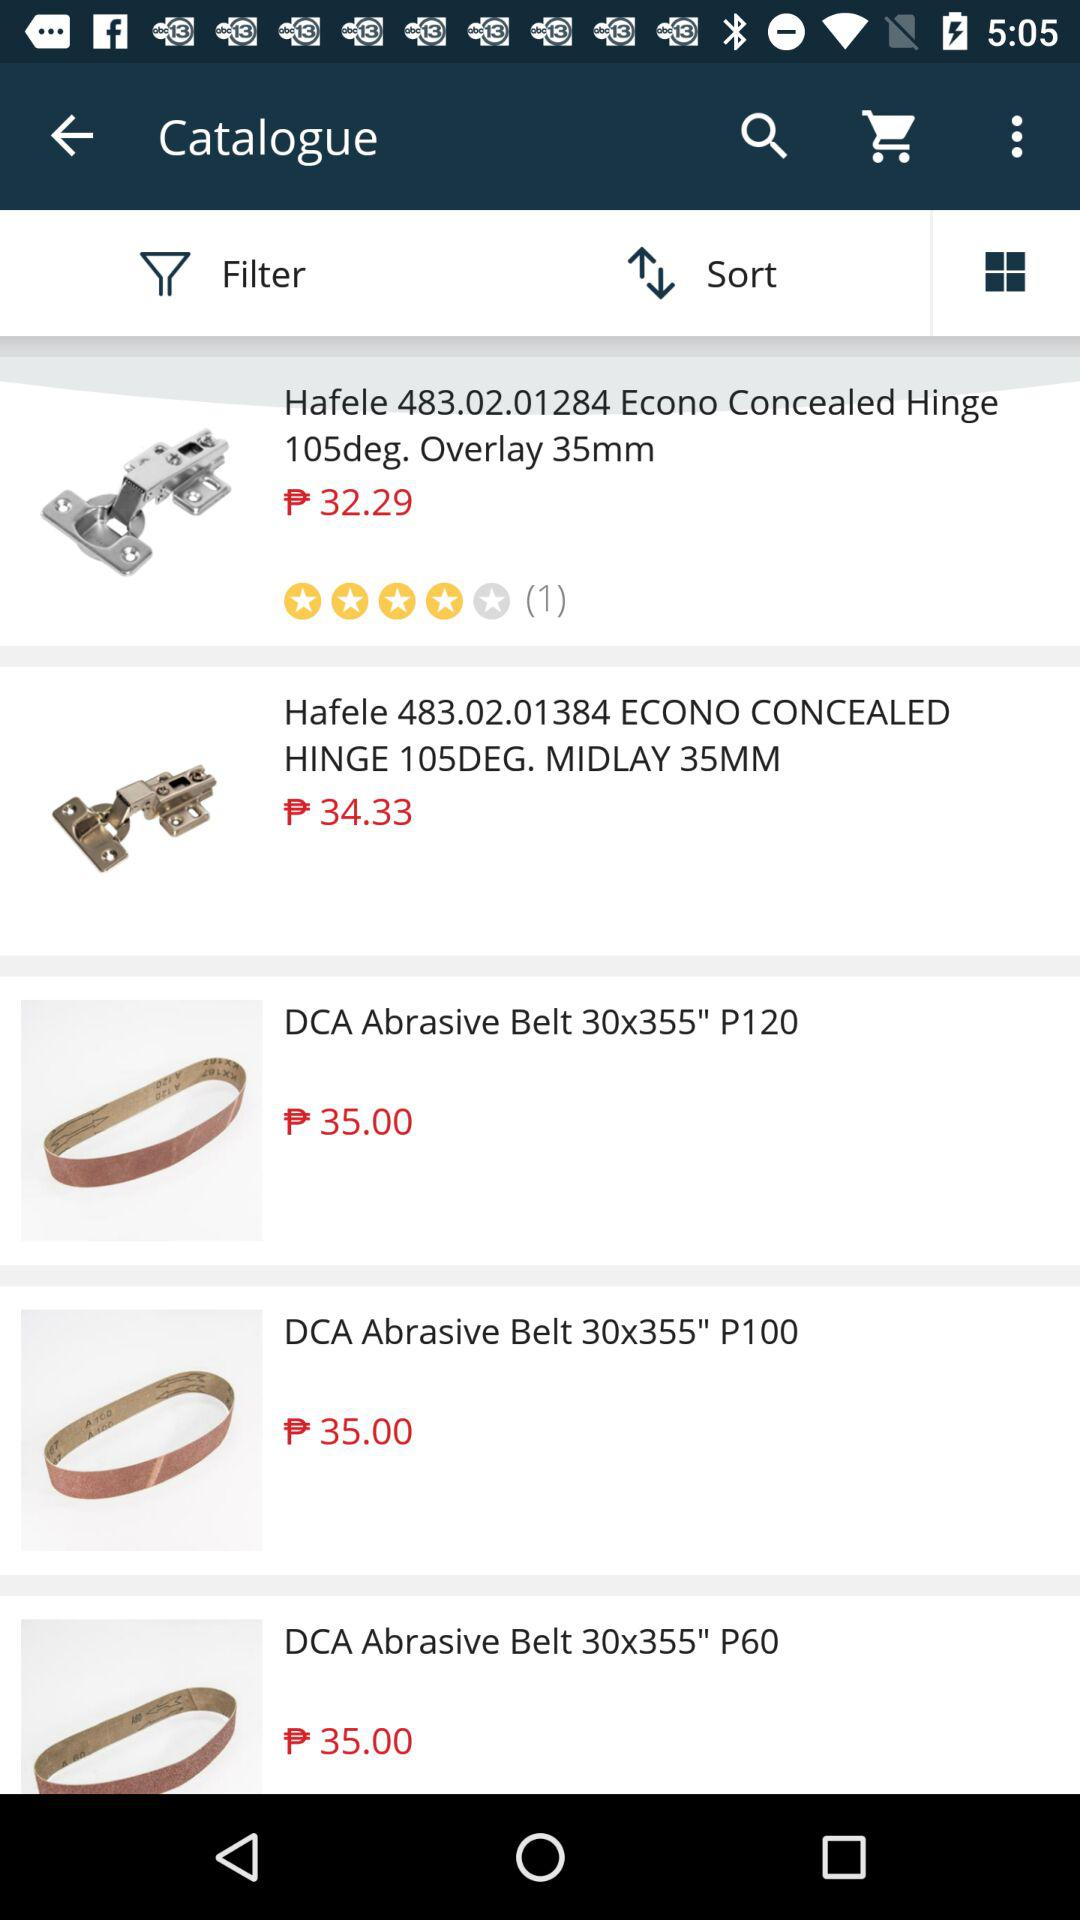How much more expensive is the Hafele 483.02.01384 ECONO CONCEALED HINGE 105DEG. MIDLAY 35MM than the Hafele 483.02.01284 Econo Concealed Hinge 105deg. Overlay 35mm?
Answer the question using a single word or phrase. 2.04 